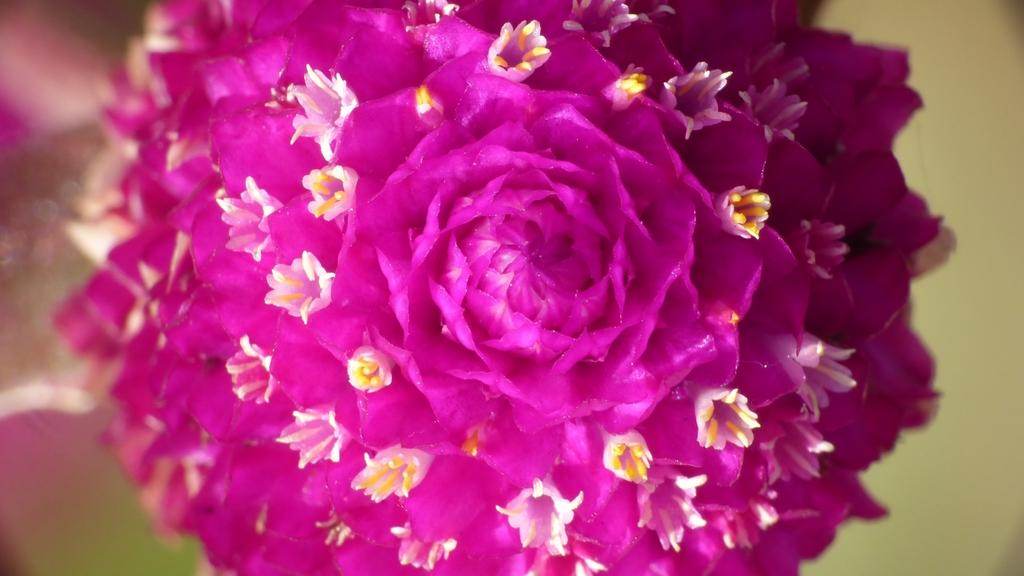What type of flower is in the image? There is a pink color flower in the image. Can you describe the background of the image? The background of the image is blurry. What type of tin can be seen on the road in the image? There is no tin or road present in the image; it only features a pink color flower with a blurry background. 